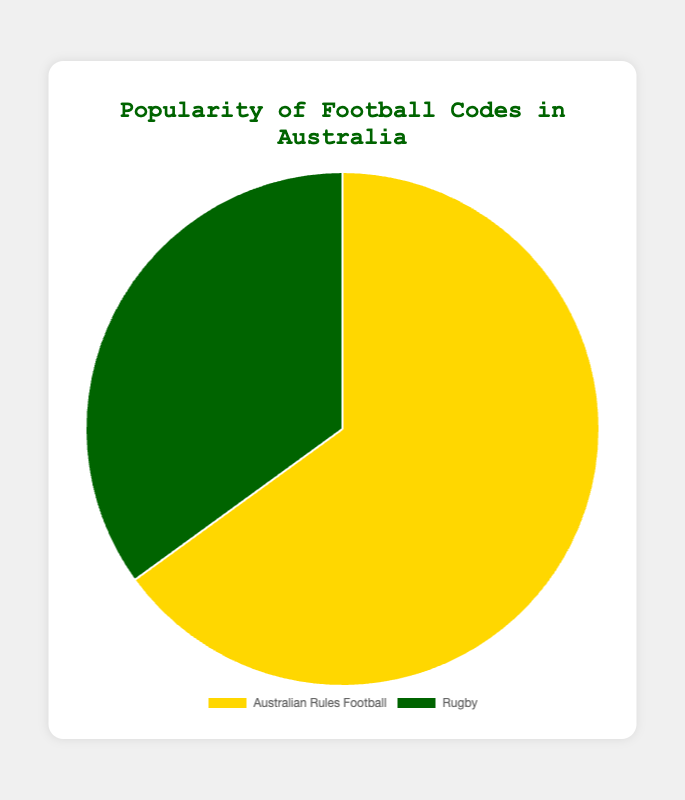Which football code is more popular in Australia? By looking at the pie chart, we see that the larger segment represents Australian Rules Football, which has 65% compared to 35% for Rugby.
Answer: Australian Rules Football What percentage of people prefer Rugby in Australia? The pie chart shows that the segment representing Rugby is labeled as 35%.
Answer: 35% How much more popular is Australian Rules Football compared to Rugby in percentage points? Subtract the percentage of Rugby (35%) from Australian Rules Football (65%). 65% - 35% = 30%.
Answer: 30% What are the colors representing Australian Rules Football and Rugby? The pie chart uses yellow (larger segment) for Australian Rules Football and green (smaller segment) for Rugby.
Answer: Yellow and Green What is the combined percentage of both football codes represented in the pie chart? The pie chart represents the popularity of the two football codes, summing their percentages yields 65% + 35% = 100%.
Answer: 100% Which segment of the pie chart is larger, the one representing Australian Rules Football or the one representing Rugby? Visually, the segment corresponding to Australian Rules Football is larger than that of Rugby.
Answer: Australian Rules Football How much less popular is Rugby compared to Australian Rules Football in percentage terms? Subtract the rugby percentage (35%) from Australian Rules Football percentage (65%). 65% - 35% = 30%.
Answer: 30% If the number of people surveyed was 2000, how many people preferred Rugby? Calculate the number of people by taking 35% of 2000. (35 / 100) * 2000 = 700.
Answer: 700 If the percentages were instead people counts out of 100 total preferences, how many more people prefer Australian Rules Football over Rugby? Subtract the counts: 65 - 35 = 30 more people prefer Australian Rules Football.
Answer: 30 If another football code is introduced with a 10% popularity, how would this affect the percentages of the existing codes? Recalculate with the new total percentage of 110%, then find the new percentages for each code as follows: 
- Australian Rules Football: (65 / 110) * 100 = ~59.1%
- Rugby: (35 / 110) * 100 = ~31.8%
- New code: 10%.
Answer: Australian Rules Football: ~59.1%, Rugby: ~31.8%, New Code: 10% 